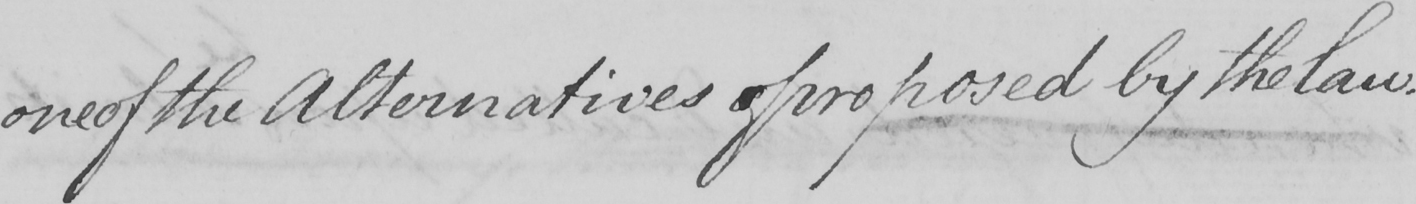What is written in this line of handwriting? one of the Alternatives of oproposed by the law . 